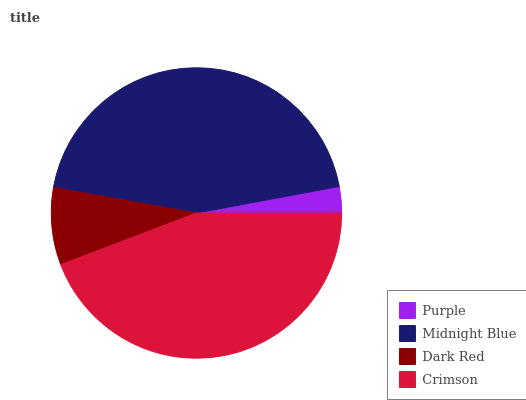Is Purple the minimum?
Answer yes or no. Yes. Is Midnight Blue the maximum?
Answer yes or no. Yes. Is Dark Red the minimum?
Answer yes or no. No. Is Dark Red the maximum?
Answer yes or no. No. Is Midnight Blue greater than Dark Red?
Answer yes or no. Yes. Is Dark Red less than Midnight Blue?
Answer yes or no. Yes. Is Dark Red greater than Midnight Blue?
Answer yes or no. No. Is Midnight Blue less than Dark Red?
Answer yes or no. No. Is Crimson the high median?
Answer yes or no. Yes. Is Dark Red the low median?
Answer yes or no. Yes. Is Purple the high median?
Answer yes or no. No. Is Purple the low median?
Answer yes or no. No. 